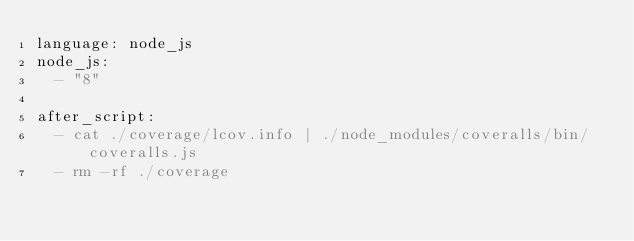<code> <loc_0><loc_0><loc_500><loc_500><_YAML_>language: node_js
node_js:
  - "8"

after_script:
  - cat ./coverage/lcov.info | ./node_modules/coveralls/bin/coveralls.js
  - rm -rf ./coverage</code> 